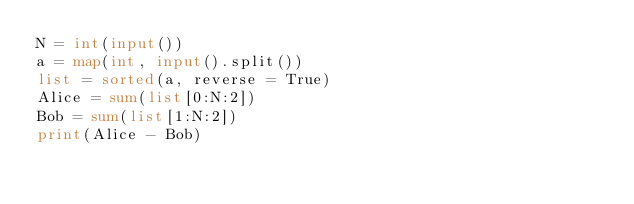<code> <loc_0><loc_0><loc_500><loc_500><_Python_>N = int(input())
a = map(int, input().split())
list = sorted(a, reverse = True)
Alice = sum(list[0:N:2])
Bob = sum(list[1:N:2])
print(Alice - Bob)</code> 